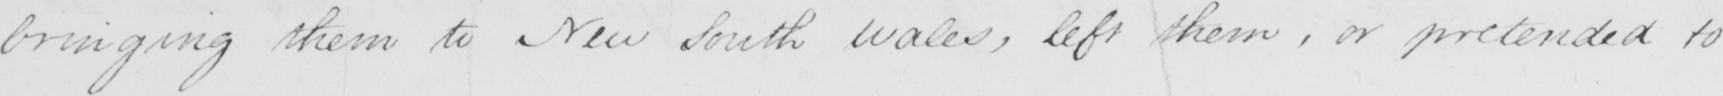What text is written in this handwritten line? bringing them to New South Wales , left them , or pretended to 